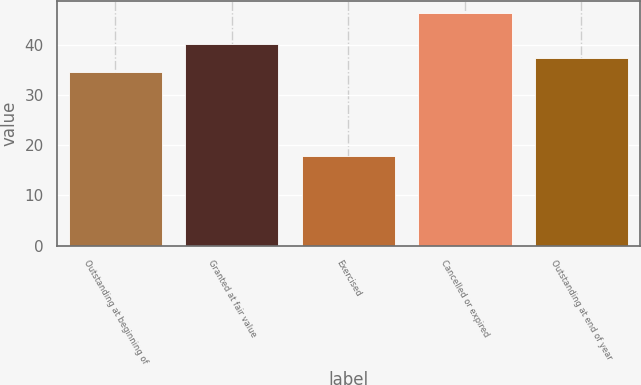Convert chart. <chart><loc_0><loc_0><loc_500><loc_500><bar_chart><fcel>Outstanding at beginning of<fcel>Granted at fair value<fcel>Exercised<fcel>Cancelled or expired<fcel>Outstanding at end of year<nl><fcel>34.55<fcel>40.25<fcel>17.85<fcel>46.38<fcel>37.4<nl></chart> 